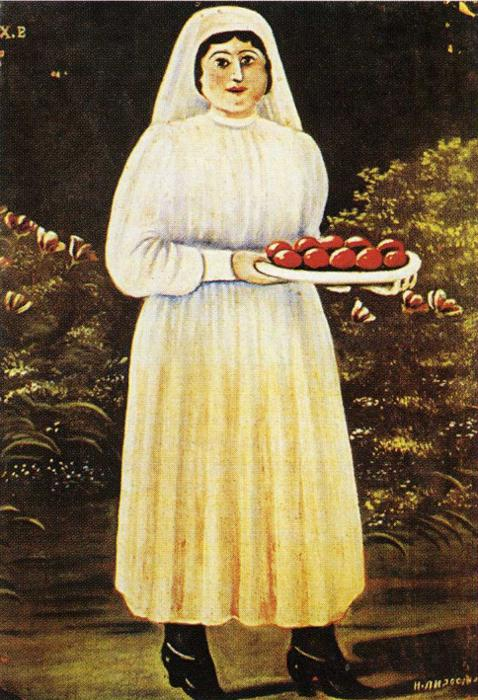If this painting could tell a story, what would it be? In a quiet village, a woman celebrates the bounties of harvest. With each apple in her tray, she commemorates the fruits of her and her community’s labor. The enchanting tree behind her serves as a guardian of prosperity, its blossoms a testament to the cycles of life and renewal. Her calm and steady gaze invites the viewer into a timeless tale of tradition and gratitude, whispering legends of the land and the enduring spirit of those who nurture it. 